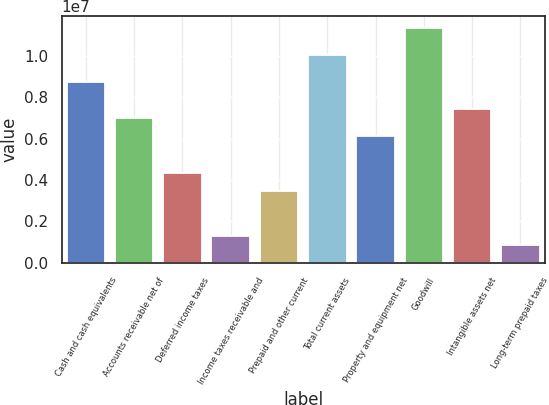Convert chart. <chart><loc_0><loc_0><loc_500><loc_500><bar_chart><fcel>Cash and cash equivalents<fcel>Accounts receivable net of<fcel>Deferred income taxes<fcel>Income taxes receivable and<fcel>Prepaid and other current<fcel>Total current assets<fcel>Property and equipment net<fcel>Goodwill<fcel>Intangible assets net<fcel>Long-term prepaid taxes<nl><fcel>8.71633e+06<fcel>6.97337e+06<fcel>4.35894e+06<fcel>1.30876e+06<fcel>3.48746e+06<fcel>1.00235e+07<fcel>6.10189e+06<fcel>1.13308e+07<fcel>7.40911e+06<fcel>873021<nl></chart> 